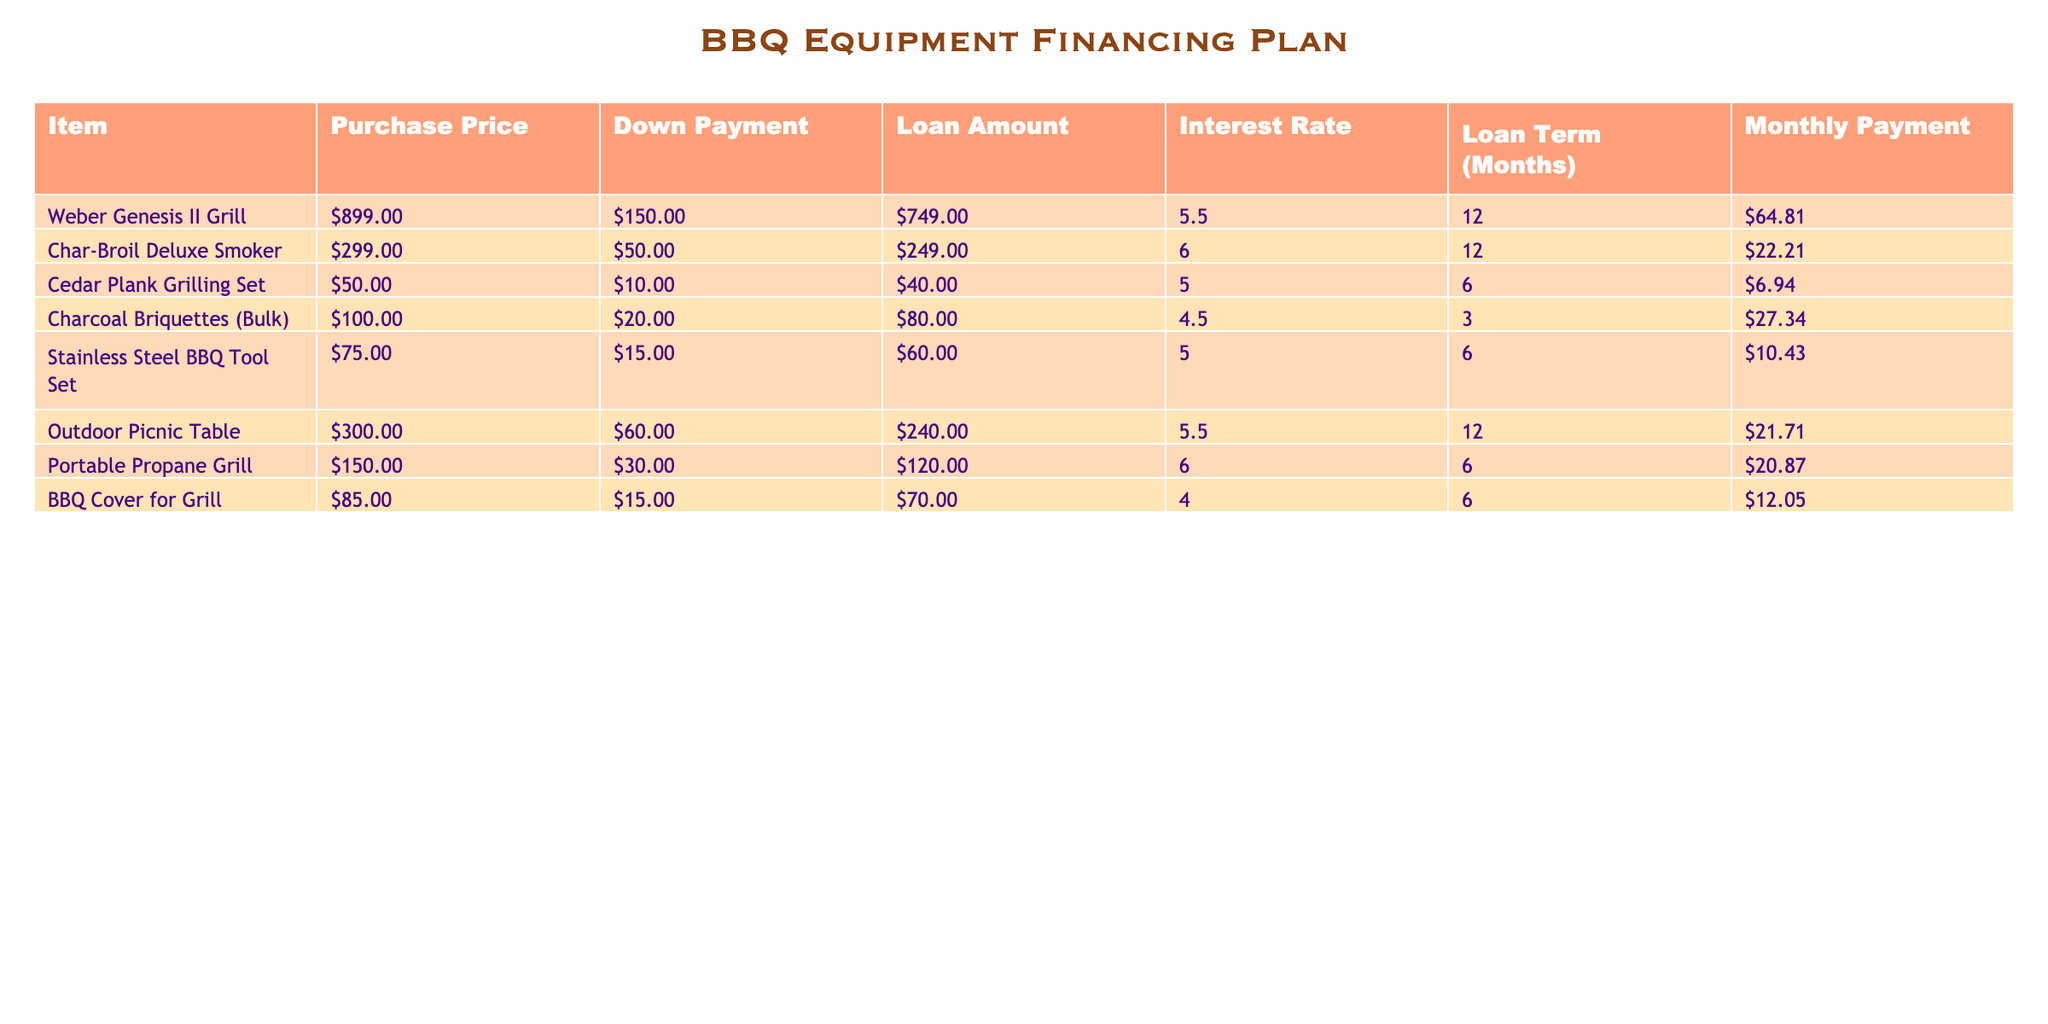What is the purchase price of the Weber Genesis II Grill? The table lists the purchasing prices for all items. Looking at the row for the Weber Genesis II Grill, the purchase price is clearly stated as 899.00.
Answer: 899.00 What is the total loan amount for items purchased? To find the total loan amount, we need to sum the Loan Amount column: 749.00 + 249.00 + 40.00 + 80.00 + 60.00 + 240.00 + 120.00 + 70.00 = 1,568.00.
Answer: 1,568.00 Does the Char-Broil Deluxe Smoker have a higher month payment than the BBQ Cover for Grill? By comparing the Monthly Payment values, we can see that the Char-Broil Deluxe Smoker costs 22.21 per month, while the BBQ Cover for Grill costs 12.05 per month. Since 22.21 > 12.05, the answer is yes.
Answer: Yes What is the average monthly payment for all items? To find the average monthly payment, sum up all monthly payments (64.81 + 22.21 + 6.94 + 27.34 + 10.43 + 21.71 + 20.87 + 12.05 = 165.36) and divide by the number of items (8). This gives us an average of 165.36 / 8 = 20.67.
Answer: 20.67 Which item has the highest interest rate? By reviewing the Interest Rate column, the highest interest rate listed is 6.0, which can be found for both the Char-Broil Deluxe Smoker and the Portable Propane Grill.
Answer: Char-Broil Deluxe Smoker and Portable Propane Grill What is the monthly payment for the Cedar Plank Grilling Set? Checking the row for the Cedar Plank Grilling Set, we see that the Monthly Payment value is listed as 6.94.
Answer: 6.94 What is the total amount paid after 12 months for the Weber Genesis II Grill? The total payment will include 12 months of the monthly payment. Thus the calculation will be: Monthly Payment (64.81) multiplied by Loan Term (12) = 64.81 * 12 = 777.72.
Answer: 777.72 Which item's purchase price is closest to its loan amount? From the table, we compare the Purchase Price and Loan Amount for each item. The items with the closest values are the Cedar Plank Grilling Set, with a Purchase Price of 50.00 and a Loan Amount of 40.00. The difference is only 10.00.
Answer: Cedar Plank Grilling Set 